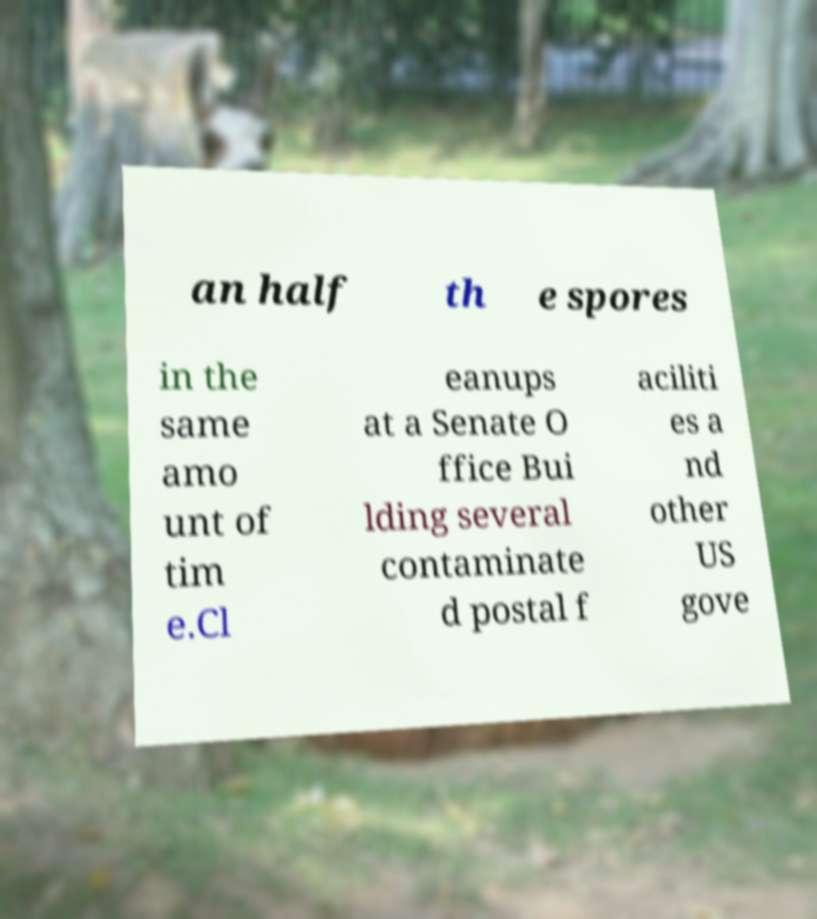There's text embedded in this image that I need extracted. Can you transcribe it verbatim? an half th e spores in the same amo unt of tim e.Cl eanups at a Senate O ffice Bui lding several contaminate d postal f aciliti es a nd other US gove 